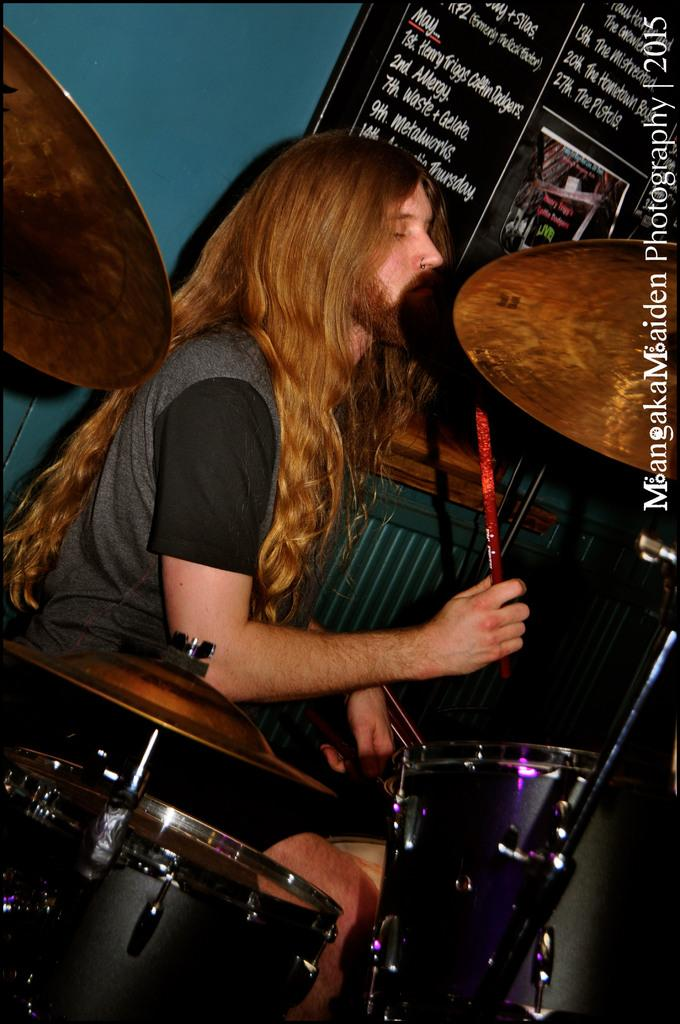Who is present in the image? There is a man in the image. What is the man holding in the image? The man is holding a stick. What can be seen in the background of the image? There are musical instruments in the background of the image. What type of creature is playing the musical instruments in the background of the image? There is no creature playing the musical instruments in the background of the image; the instruments are simply visible. 